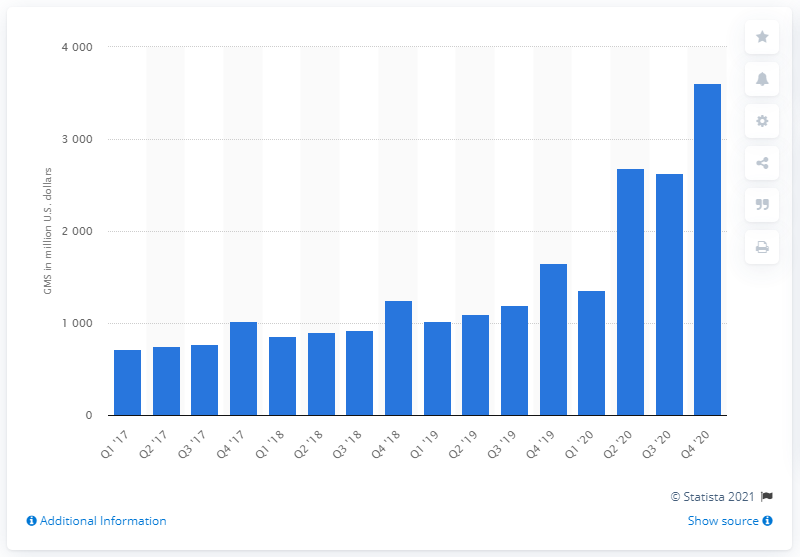Identify some key points in this picture. In the fourth quarter of 2020, the Gross Merchandise Sales (GMS) of Etsy was 3605.1 million dollars. In the quarter prior to 2020, Etsy's GMS (gross merchandise sales) was 1655.72. 